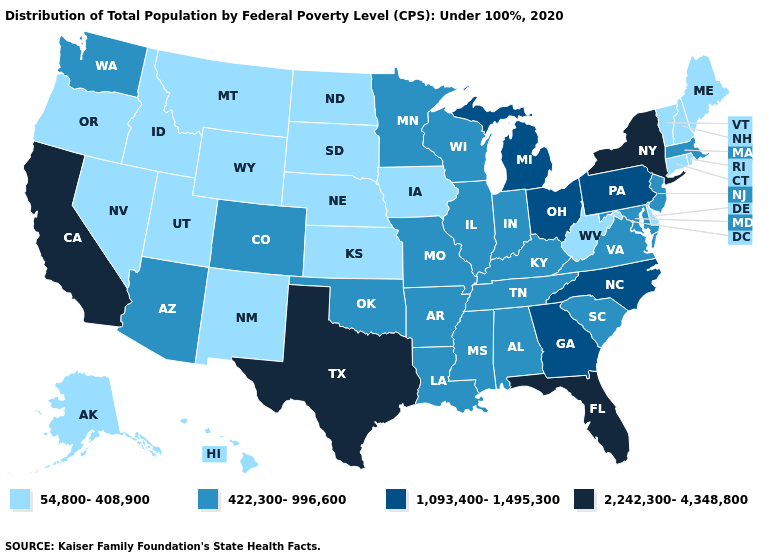Name the states that have a value in the range 1,093,400-1,495,300?
Quick response, please. Georgia, Michigan, North Carolina, Ohio, Pennsylvania. Name the states that have a value in the range 422,300-996,600?
Concise answer only. Alabama, Arizona, Arkansas, Colorado, Illinois, Indiana, Kentucky, Louisiana, Maryland, Massachusetts, Minnesota, Mississippi, Missouri, New Jersey, Oklahoma, South Carolina, Tennessee, Virginia, Washington, Wisconsin. Which states hav the highest value in the South?
Short answer required. Florida, Texas. Name the states that have a value in the range 2,242,300-4,348,800?
Be succinct. California, Florida, New York, Texas. Name the states that have a value in the range 1,093,400-1,495,300?
Concise answer only. Georgia, Michigan, North Carolina, Ohio, Pennsylvania. Among the states that border North Dakota , which have the highest value?
Write a very short answer. Minnesota. What is the highest value in states that border Massachusetts?
Answer briefly. 2,242,300-4,348,800. Name the states that have a value in the range 422,300-996,600?
Quick response, please. Alabama, Arizona, Arkansas, Colorado, Illinois, Indiana, Kentucky, Louisiana, Maryland, Massachusetts, Minnesota, Mississippi, Missouri, New Jersey, Oklahoma, South Carolina, Tennessee, Virginia, Washington, Wisconsin. What is the highest value in the USA?
Write a very short answer. 2,242,300-4,348,800. What is the value of Mississippi?
Give a very brief answer. 422,300-996,600. Is the legend a continuous bar?
Answer briefly. No. What is the lowest value in the USA?
Give a very brief answer. 54,800-408,900. What is the lowest value in the USA?
Keep it brief. 54,800-408,900. Among the states that border Oregon , which have the lowest value?
Write a very short answer. Idaho, Nevada. What is the value of Nevada?
Answer briefly. 54,800-408,900. 